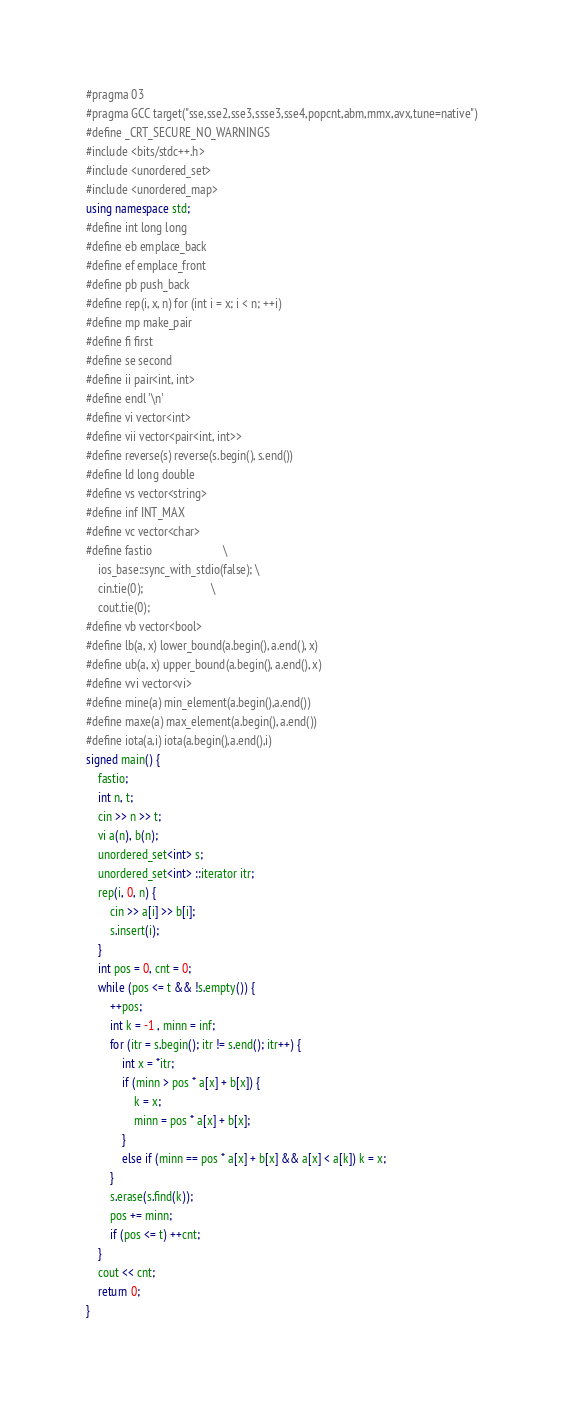<code> <loc_0><loc_0><loc_500><loc_500><_C++_>#pragma 03
#pragma GCC target("sse,sse2,sse3,ssse3,sse4,popcnt,abm,mmx,avx,tune=native")
#define _CRT_SECURE_NO_WARNINGS
#include <bits/stdc++.h>
#include <unordered_set>
#include <unordered_map>
using namespace std;
#define int long long
#define eb emplace_back
#define ef emplace_front
#define pb push_back
#define rep(i, x, n) for (int i = x; i < n; ++i)
#define mp make_pair
#define fi first
#define se second
#define ii pair<int, int>
#define endl '\n'
#define vi vector<int>
#define vii vector<pair<int, int>>
#define reverse(s) reverse(s.begin(), s.end())
#define ld long double
#define vs vector<string>
#define inf INT_MAX
#define vc vector<char>
#define fastio                        \
    ios_base::sync_with_stdio(false); \
    cin.tie(0);                       \
    cout.tie(0);
#define vb vector<bool>
#define lb(a, x) lower_bound(a.begin(), a.end(), x)
#define ub(a, x) upper_bound(a.begin(), a.end(), x) 
#define vvi vector<vi>
#define mine(a) min_element(a.begin(),a.end())
#define maxe(a) max_element(a.begin(), a.end())
#define iota(a,i) iota(a.begin(),a.end(),i)
signed main() {
    fastio;
    int n, t;
    cin >> n >> t;
    vi a(n), b(n);
    unordered_set<int> s;
    unordered_set<int> ::iterator itr;
    rep(i, 0, n) {
        cin >> a[i] >> b[i];
        s.insert(i);
    }
    int pos = 0, cnt = 0;
    while (pos <= t && !s.empty()) {
        ++pos;
        int k = -1 , minn = inf;
        for (itr = s.begin(); itr != s.end(); itr++) {
            int x = *itr;
            if (minn > pos * a[x] + b[x]) {
                k = x;
                minn = pos * a[x] + b[x];
            }
            else if (minn == pos * a[x] + b[x] && a[x] < a[k]) k = x;
        }
        s.erase(s.find(k));
        pos += minn;
        if (pos <= t) ++cnt;
    }
    cout << cnt;
    return 0;
}</code> 